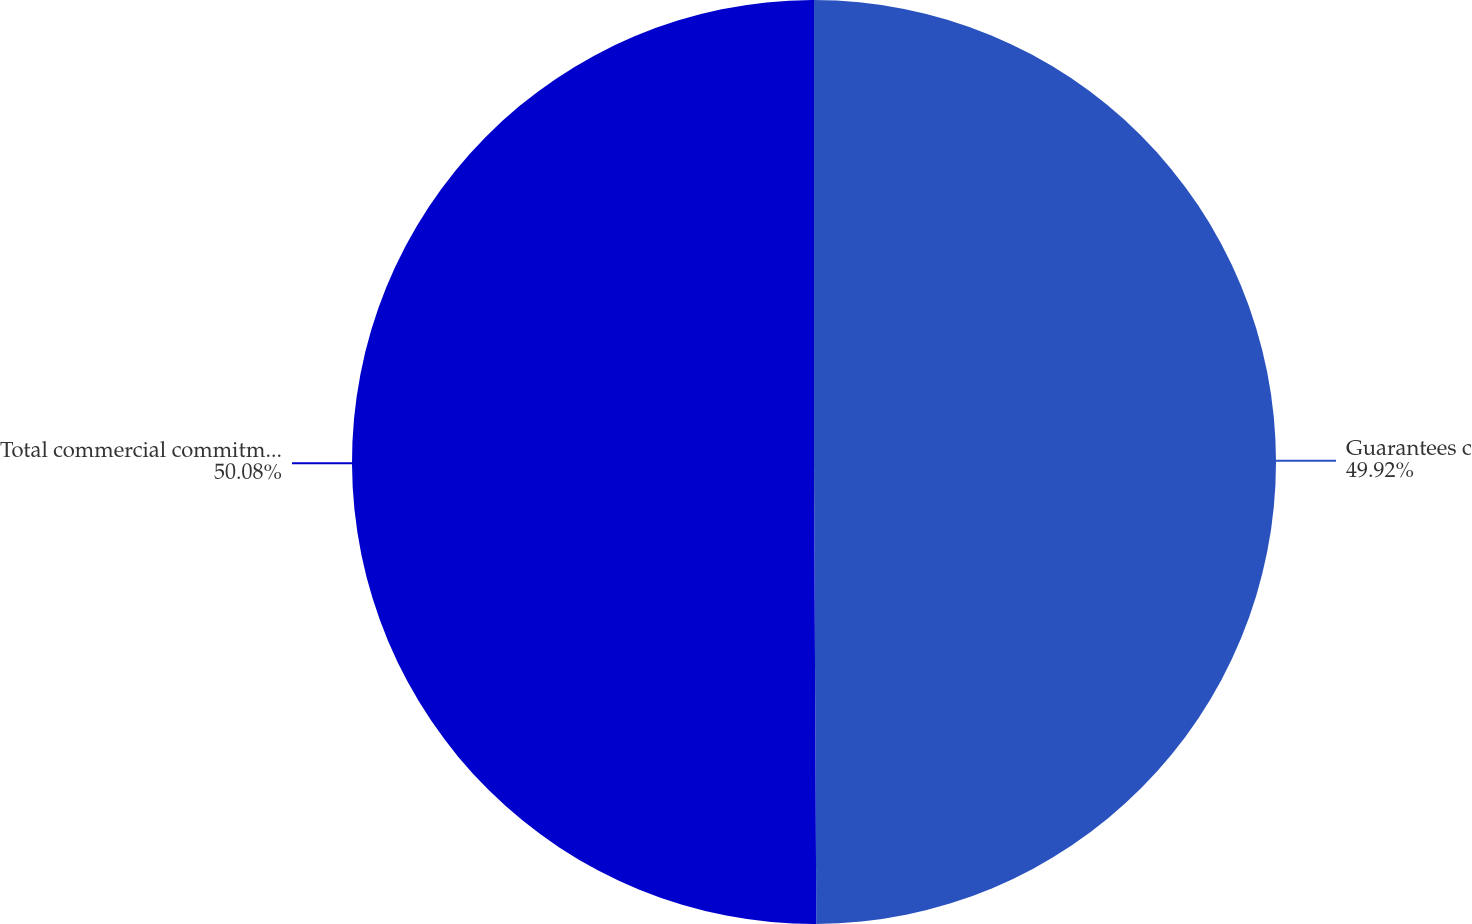<chart> <loc_0><loc_0><loc_500><loc_500><pie_chart><fcel>Guarantees c<fcel>Total commercial commitments<nl><fcel>49.92%<fcel>50.08%<nl></chart> 